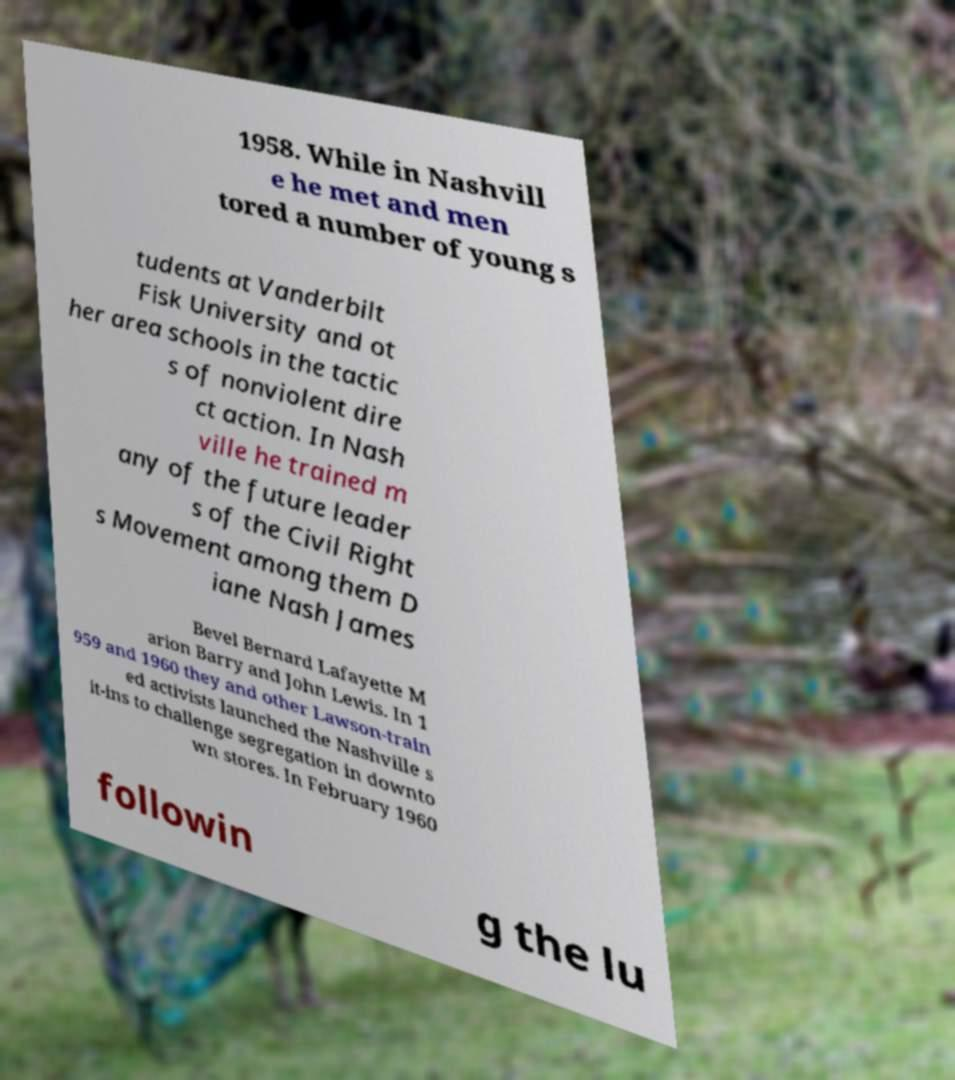Can you read and provide the text displayed in the image?This photo seems to have some interesting text. Can you extract and type it out for me? 1958. While in Nashvill e he met and men tored a number of young s tudents at Vanderbilt Fisk University and ot her area schools in the tactic s of nonviolent dire ct action. In Nash ville he trained m any of the future leader s of the Civil Right s Movement among them D iane Nash James Bevel Bernard Lafayette M arion Barry and John Lewis. In 1 959 and 1960 they and other Lawson-train ed activists launched the Nashville s it-ins to challenge segregation in downto wn stores. In February 1960 followin g the lu 